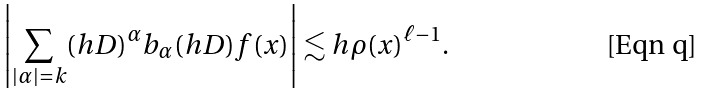<formula> <loc_0><loc_0><loc_500><loc_500>\left | \sum _ { | \alpha | = k } ( h D ) ^ { \alpha } b _ { \alpha } ( h D ) f ( x ) \right | \lesssim h \rho ( x ) ^ { \ell - 1 } .</formula> 